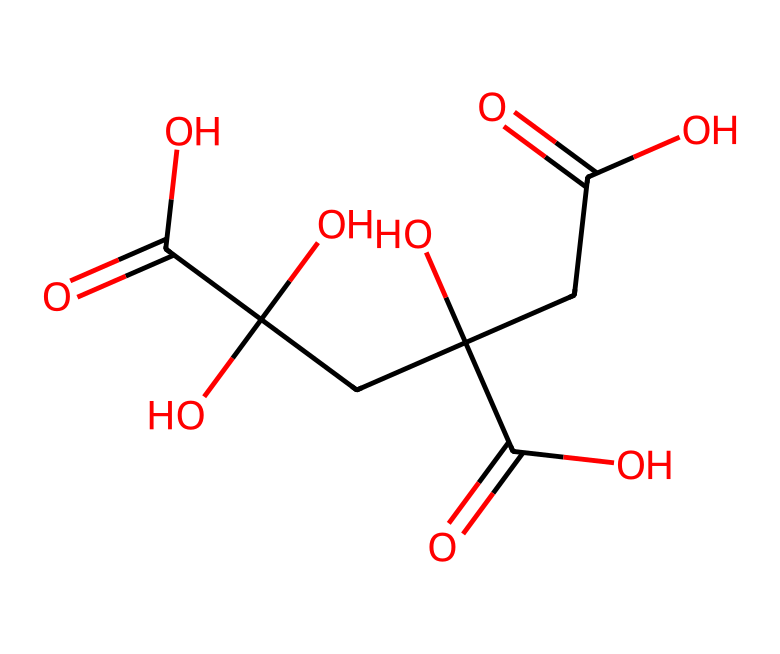What is the name of this chemical? The given SMILES representation corresponds to citric acid, which is commonly used in cleaning products for its acidic properties and ability to chelate metal ions.
Answer: citric acid How many carbon atoms are in citric acid? By analyzing the structure, we can count three carbon atoms in the backbone of citric acid as reflected in the SMILES notation.
Answer: three What functional groups are present in citric acid? The SMILES notation indicates the presence of hydroxyl (-OH) and carboxylic acid (-COOH) functional groups, which are key characteristics of citric acid.
Answer: hydroxyl and carboxylic acid What is the total number of hydroxyl groups in citric acid? By assessing the chemical, we can see there are three hydroxyl groups present, linked to carbons in the structure.
Answer: three What type of acid is citric acid considered? Citric acid is classified as a weak organic acid due to its ability to partially dissociate in solution, distinguishing it from stronger acids.
Answer: weak organic acid How many double bonds are in citric acid? The structure shows that citric acid has three double bonds, specifically in the carbonyl groups associated with the carboxylic acids.
Answer: three 